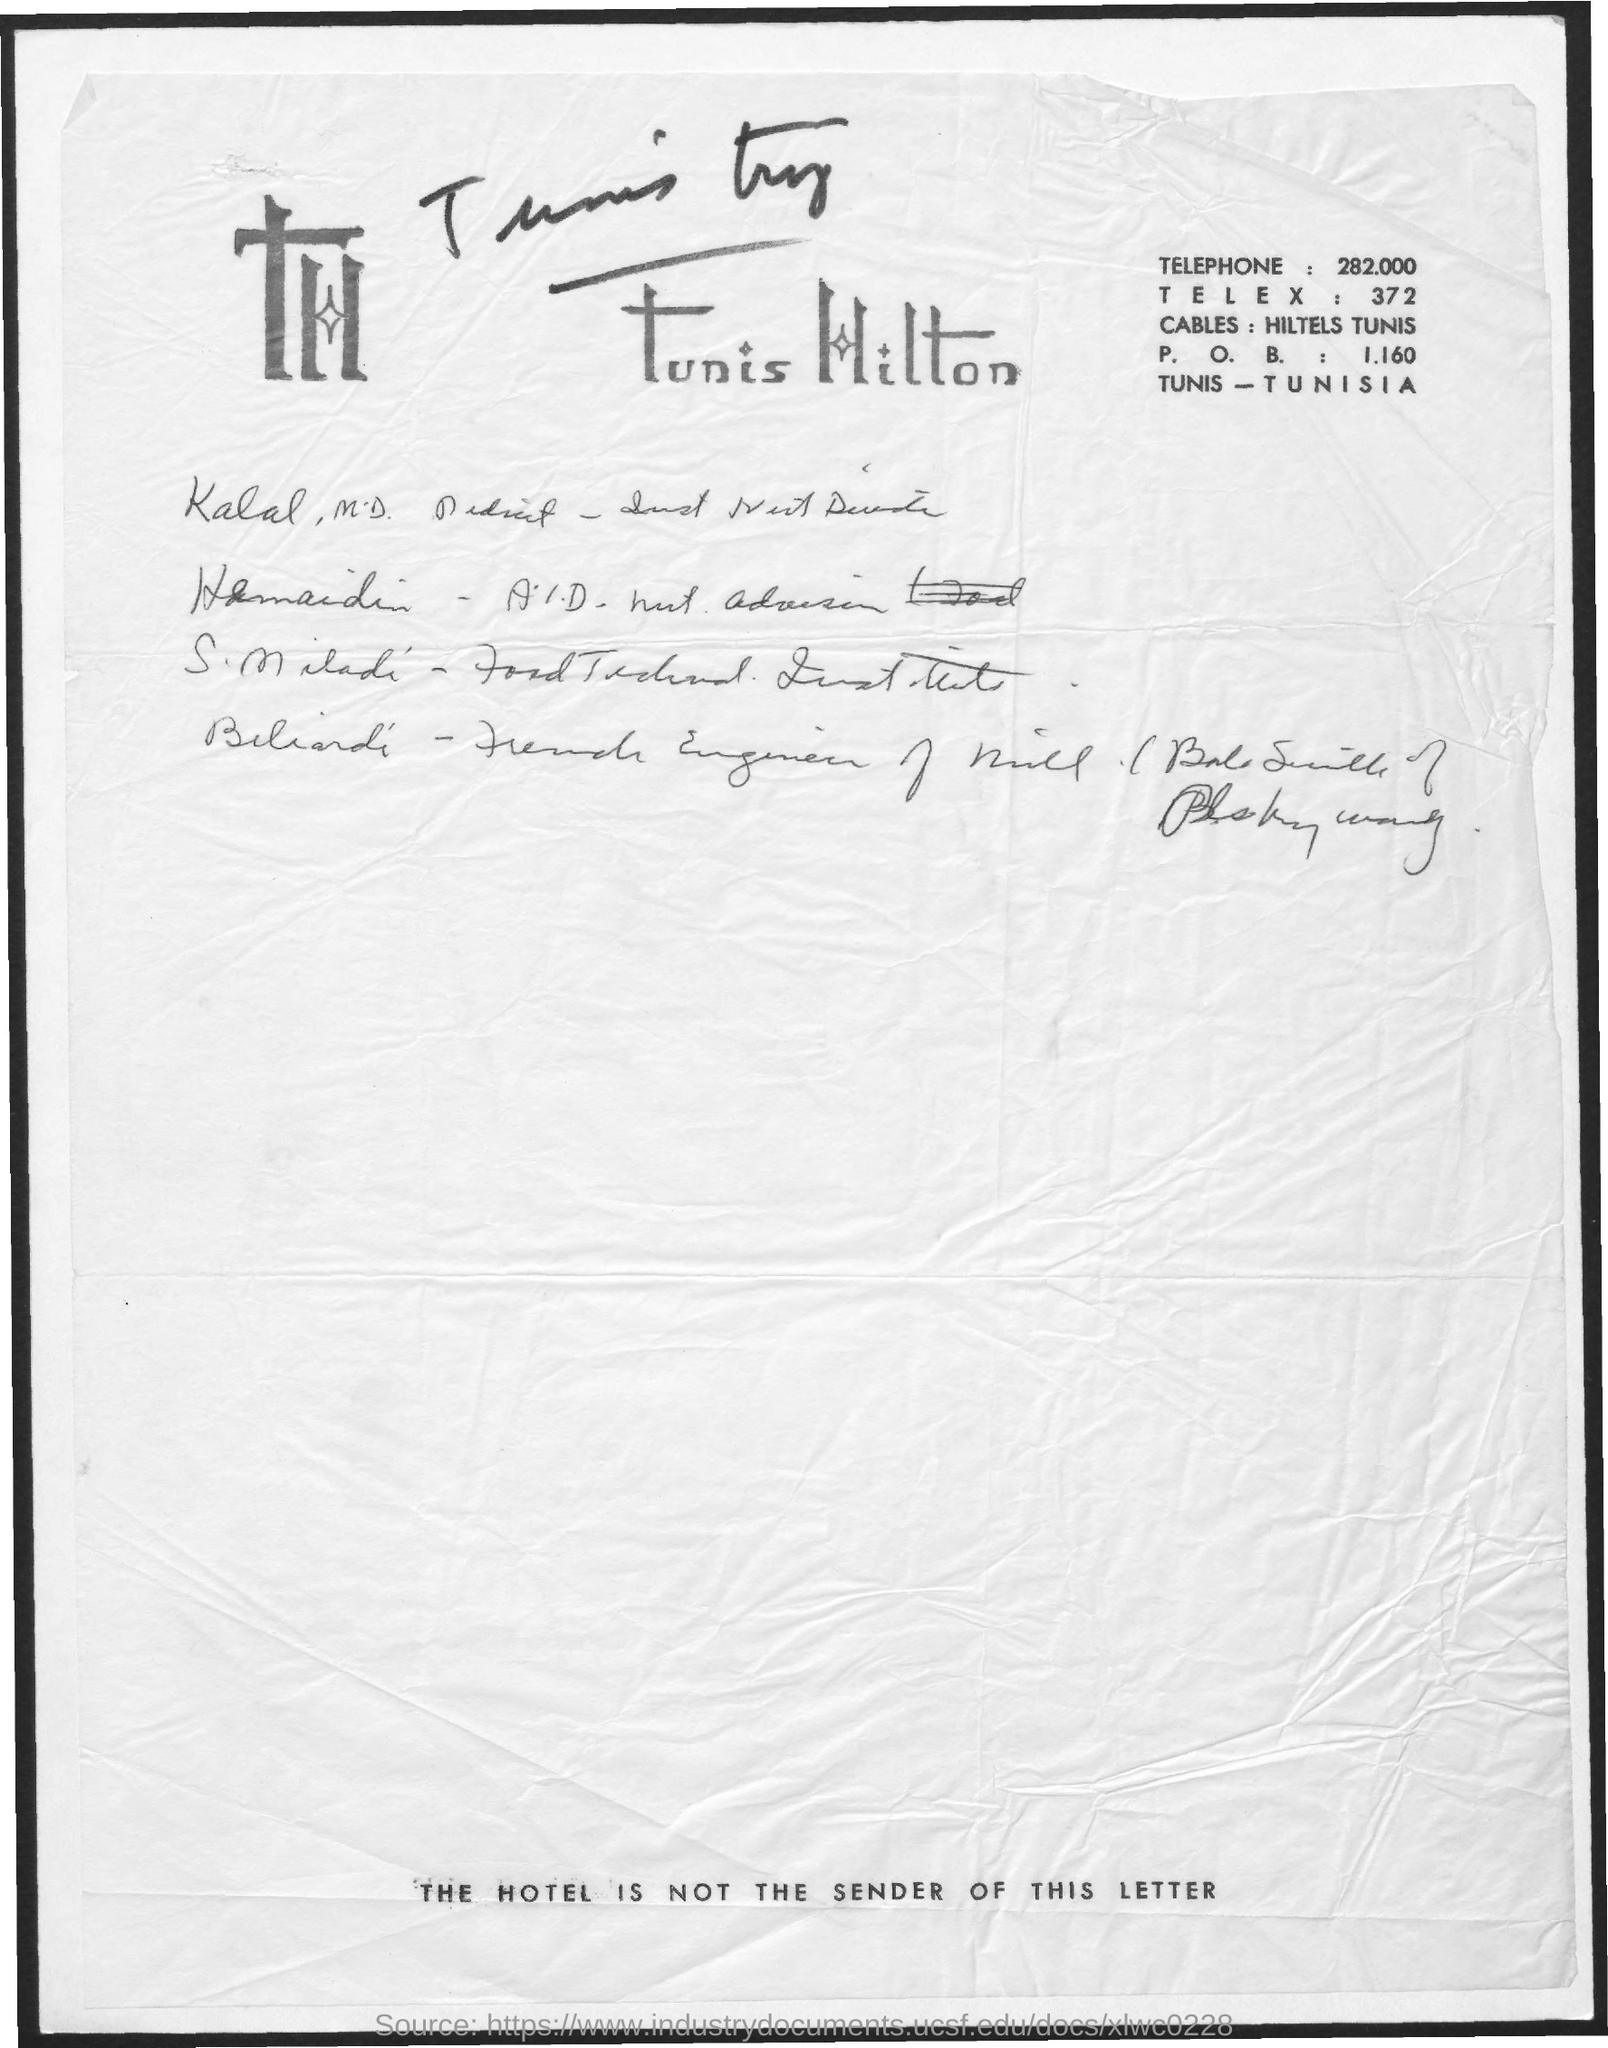What is the Telephone?
Ensure brevity in your answer.  282.000. What is the TELEX?
Your answer should be very brief. 372. What is the P. O. B.?
Offer a terse response. 1.160. 